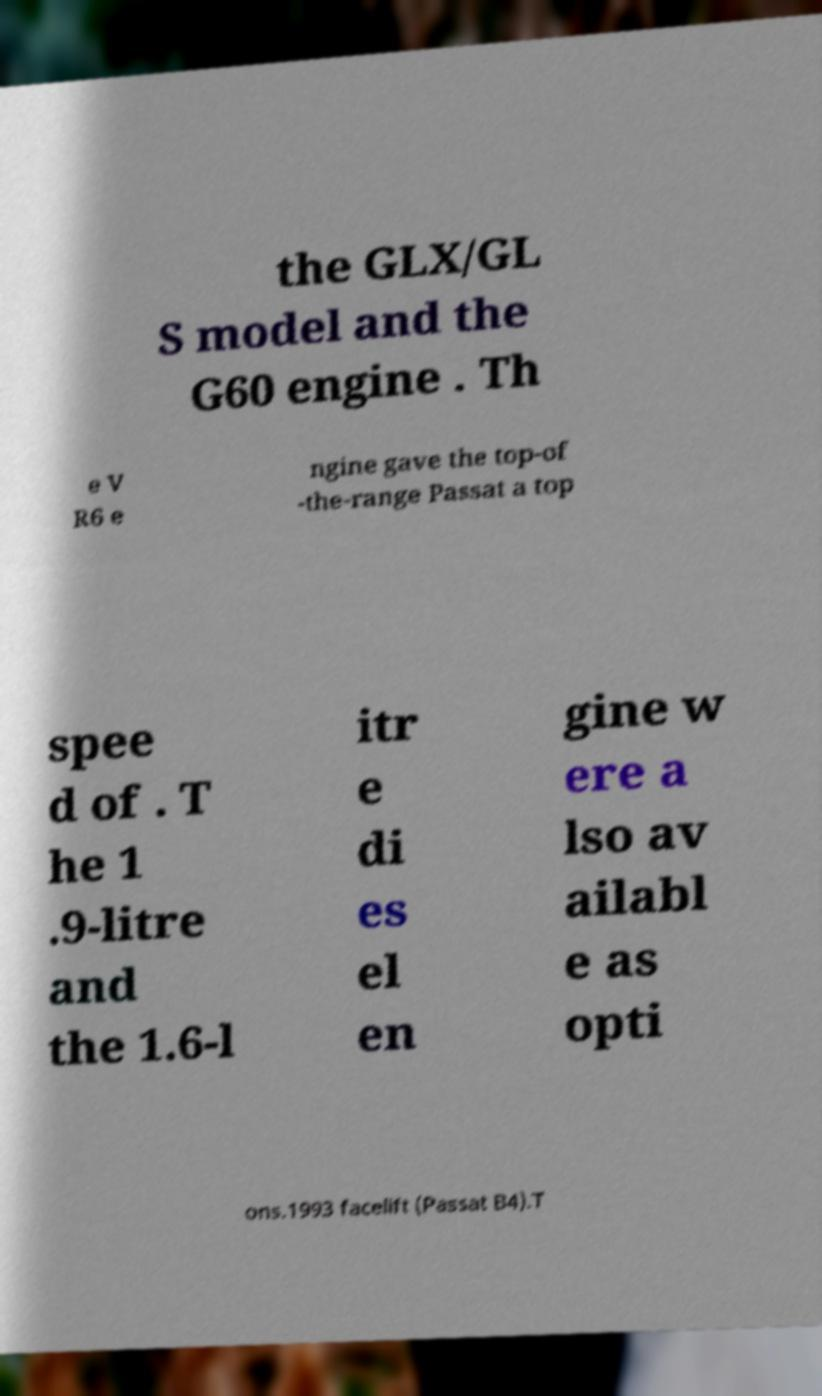Please identify and transcribe the text found in this image. the GLX/GL S model and the G60 engine . Th e V R6 e ngine gave the top-of -the-range Passat a top spee d of . T he 1 .9-litre and the 1.6-l itr e di es el en gine w ere a lso av ailabl e as opti ons.1993 facelift (Passat B4).T 